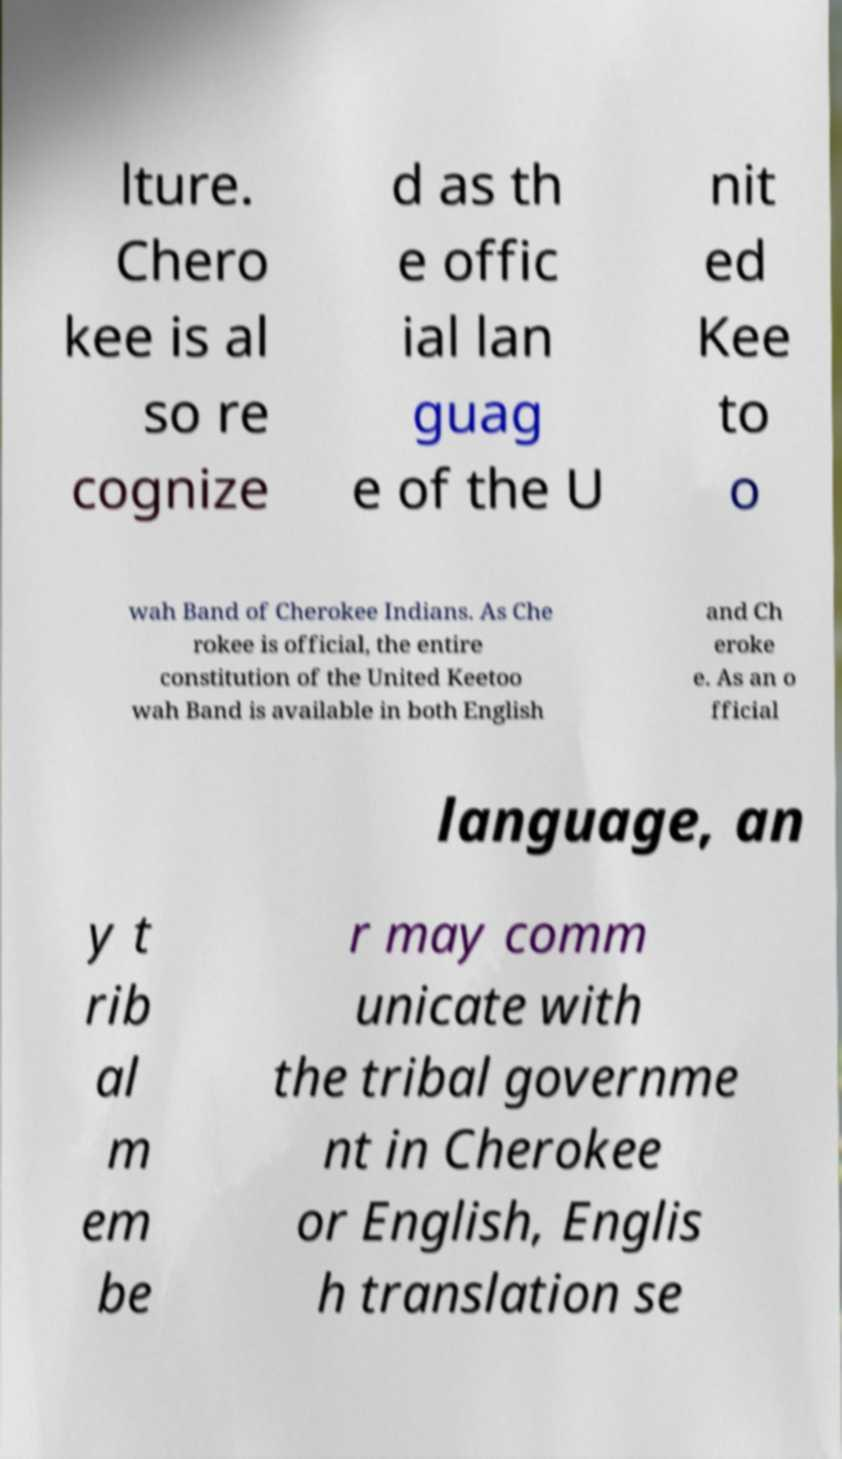Can you accurately transcribe the text from the provided image for me? lture. Chero kee is al so re cognize d as th e offic ial lan guag e of the U nit ed Kee to o wah Band of Cherokee Indians. As Che rokee is official, the entire constitution of the United Keetoo wah Band is available in both English and Ch eroke e. As an o fficial language, an y t rib al m em be r may comm unicate with the tribal governme nt in Cherokee or English, Englis h translation se 